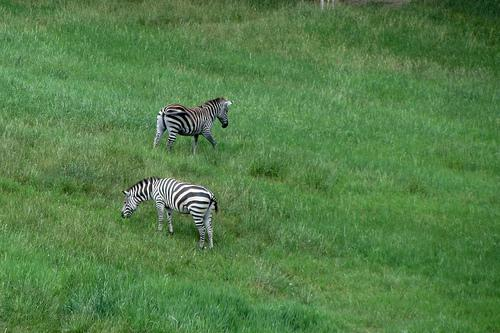Question: what animals are in the picture?
Choices:
A. Zebras.
B. Cows.
C. Lions.
D. Giraffes.
Answer with the letter. Answer: A Question: what are the zebras doing?
Choices:
A. Sleeping.
B. Drinking.
C. Running.
D. Eating and walking.
Answer with the letter. Answer: D Question: what color are the zebras' tails?
Choices:
A. White.
B. Brown.
C. Gray.
D. Black.
Answer with the letter. Answer: D 